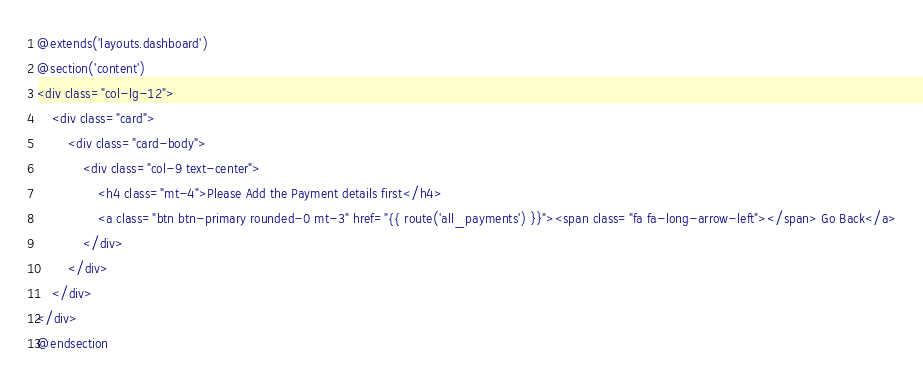<code> <loc_0><loc_0><loc_500><loc_500><_PHP_>@extends('layouts.dashboard')
@section('content')
<div class="col-lg-12">
    <div class="card">
        <div class="card-body">
            <div class="col-9 text-center">
                <h4 class="mt-4">Please Add the Payment details first</h4>
                <a class="btn btn-primary rounded-0 mt-3" href="{{ route('all_payments') }}"><span class="fa fa-long-arrow-left"></span> Go Back</a>
            </div>
        </div>
    </div>
</div>
@endsection</code> 